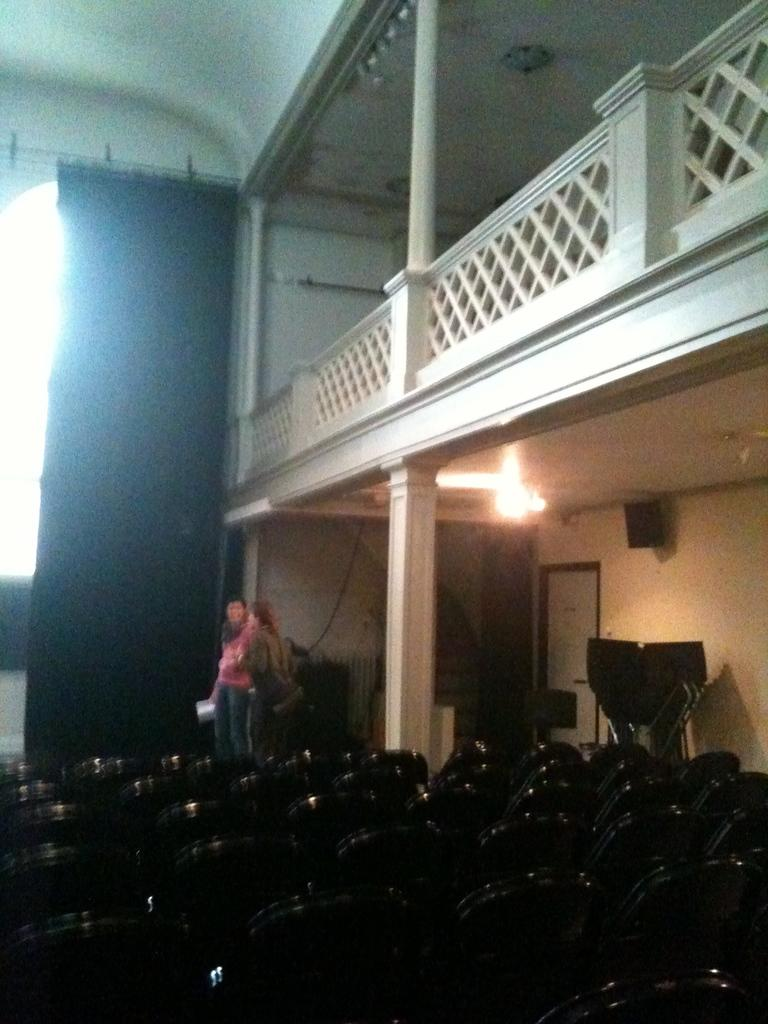How many people are present in the image? There are two people in the image. What can be seen hanging in the image? There is a curtain and a light hanging from the roof in the image. What type of furniture is visible in the image? There are chairs in the image. Can you describe the lighting in the image? There is a light hanging from the roof in the image. What other objects can be seen in the image? There are other objects in the image, but their specific details are not mentioned in the provided facts. What type of skirt is the flame wearing in the image? There is no flame or skirt present in the image. How many copies of the book are visible on the table in the image? There is no mention of a book or table in the provided facts, so it is not possible to answer this question. 